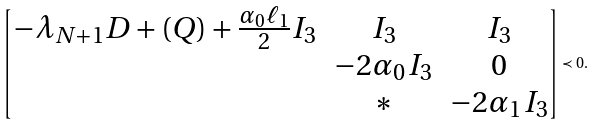Convert formula to latex. <formula><loc_0><loc_0><loc_500><loc_500>\begin{bmatrix} - \lambda _ { N + 1 } D + \left ( Q \right ) + \frac { \alpha _ { 0 } \ell _ { 1 } } { 2 } I _ { 3 } & I _ { 3 } & I _ { 3 } \\ & - 2 \alpha _ { 0 } I _ { 3 } & 0 \\ & * & - 2 \alpha _ { 1 } I _ { 3 } \end{bmatrix} \prec 0 .</formula> 